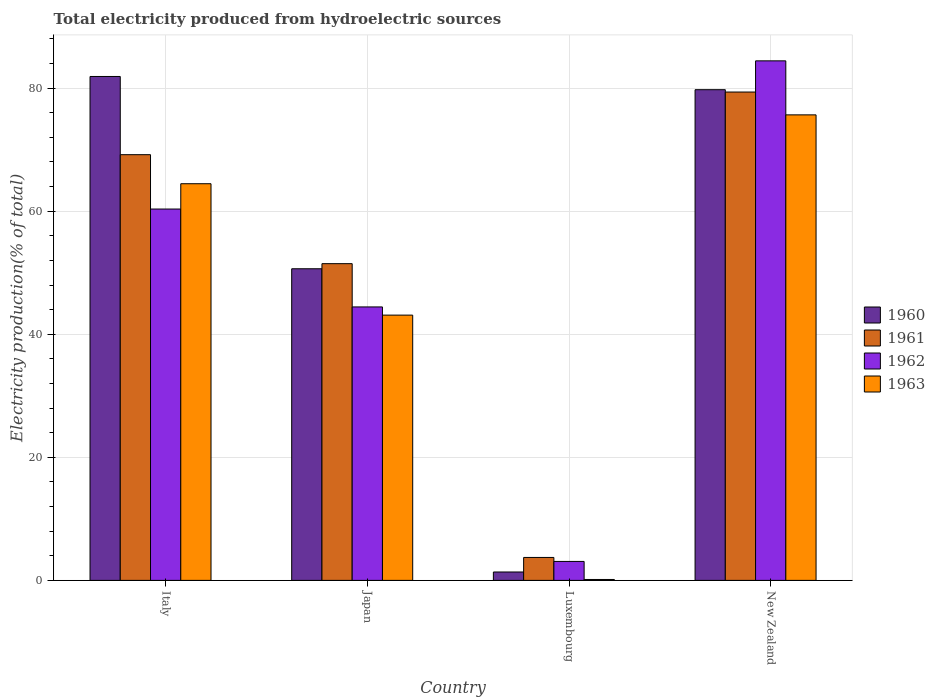How many groups of bars are there?
Make the answer very short. 4. Are the number of bars per tick equal to the number of legend labels?
Provide a short and direct response. Yes. Are the number of bars on each tick of the X-axis equal?
Your answer should be very brief. Yes. How many bars are there on the 2nd tick from the left?
Your answer should be compact. 4. What is the label of the 3rd group of bars from the left?
Offer a very short reply. Luxembourg. What is the total electricity produced in 1962 in Japan?
Offer a very short reply. 44.44. Across all countries, what is the maximum total electricity produced in 1963?
Your answer should be compact. 75.66. Across all countries, what is the minimum total electricity produced in 1961?
Ensure brevity in your answer.  3.73. In which country was the total electricity produced in 1962 maximum?
Your answer should be compact. New Zealand. In which country was the total electricity produced in 1963 minimum?
Keep it short and to the point. Luxembourg. What is the total total electricity produced in 1961 in the graph?
Your answer should be compact. 203.77. What is the difference between the total electricity produced in 1961 in Italy and that in New Zealand?
Your answer should be compact. -10.18. What is the difference between the total electricity produced in 1962 in Japan and the total electricity produced in 1963 in Italy?
Your response must be concise. -20.02. What is the average total electricity produced in 1962 per country?
Give a very brief answer. 48.08. What is the difference between the total electricity produced of/in 1962 and total electricity produced of/in 1961 in Italy?
Make the answer very short. -8.84. What is the ratio of the total electricity produced in 1962 in Japan to that in New Zealand?
Provide a short and direct response. 0.53. What is the difference between the highest and the second highest total electricity produced in 1961?
Provide a succinct answer. -17.71. What is the difference between the highest and the lowest total electricity produced in 1961?
Offer a terse response. 75.64. What does the 3rd bar from the right in Luxembourg represents?
Make the answer very short. 1961. Is it the case that in every country, the sum of the total electricity produced in 1963 and total electricity produced in 1960 is greater than the total electricity produced in 1962?
Keep it short and to the point. No. How many bars are there?
Offer a very short reply. 16. Are all the bars in the graph horizontal?
Your answer should be very brief. No. Does the graph contain any zero values?
Your answer should be very brief. No. Does the graph contain grids?
Your response must be concise. Yes. What is the title of the graph?
Ensure brevity in your answer.  Total electricity produced from hydroelectric sources. What is the label or title of the Y-axis?
Provide a succinct answer. Electricity production(% of total). What is the Electricity production(% of total) of 1960 in Italy?
Your response must be concise. 81.9. What is the Electricity production(% of total) in 1961 in Italy?
Provide a succinct answer. 69.19. What is the Electricity production(% of total) of 1962 in Italy?
Your answer should be compact. 60.35. What is the Electricity production(% of total) in 1963 in Italy?
Your answer should be compact. 64.47. What is the Electricity production(% of total) of 1960 in Japan?
Give a very brief answer. 50.65. What is the Electricity production(% of total) of 1961 in Japan?
Your response must be concise. 51.48. What is the Electricity production(% of total) in 1962 in Japan?
Ensure brevity in your answer.  44.44. What is the Electricity production(% of total) in 1963 in Japan?
Offer a terse response. 43.11. What is the Electricity production(% of total) in 1960 in Luxembourg?
Your answer should be compact. 1.37. What is the Electricity production(% of total) of 1961 in Luxembourg?
Ensure brevity in your answer.  3.73. What is the Electricity production(% of total) of 1962 in Luxembourg?
Provide a succinct answer. 3.08. What is the Electricity production(% of total) of 1963 in Luxembourg?
Your answer should be very brief. 0.15. What is the Electricity production(% of total) of 1960 in New Zealand?
Keep it short and to the point. 79.75. What is the Electricity production(% of total) of 1961 in New Zealand?
Offer a very short reply. 79.37. What is the Electricity production(% of total) in 1962 in New Zealand?
Ensure brevity in your answer.  84.44. What is the Electricity production(% of total) in 1963 in New Zealand?
Make the answer very short. 75.66. Across all countries, what is the maximum Electricity production(% of total) of 1960?
Your answer should be compact. 81.9. Across all countries, what is the maximum Electricity production(% of total) of 1961?
Make the answer very short. 79.37. Across all countries, what is the maximum Electricity production(% of total) in 1962?
Provide a succinct answer. 84.44. Across all countries, what is the maximum Electricity production(% of total) in 1963?
Your answer should be compact. 75.66. Across all countries, what is the minimum Electricity production(% of total) in 1960?
Ensure brevity in your answer.  1.37. Across all countries, what is the minimum Electricity production(% of total) in 1961?
Offer a very short reply. 3.73. Across all countries, what is the minimum Electricity production(% of total) of 1962?
Keep it short and to the point. 3.08. Across all countries, what is the minimum Electricity production(% of total) of 1963?
Your answer should be very brief. 0.15. What is the total Electricity production(% of total) of 1960 in the graph?
Keep it short and to the point. 213.67. What is the total Electricity production(% of total) in 1961 in the graph?
Your answer should be very brief. 203.77. What is the total Electricity production(% of total) in 1962 in the graph?
Ensure brevity in your answer.  192.32. What is the total Electricity production(% of total) in 1963 in the graph?
Your answer should be compact. 183.39. What is the difference between the Electricity production(% of total) of 1960 in Italy and that in Japan?
Your answer should be compact. 31.25. What is the difference between the Electricity production(% of total) in 1961 in Italy and that in Japan?
Keep it short and to the point. 17.71. What is the difference between the Electricity production(% of total) of 1962 in Italy and that in Japan?
Your response must be concise. 15.91. What is the difference between the Electricity production(% of total) in 1963 in Italy and that in Japan?
Offer a terse response. 21.35. What is the difference between the Electricity production(% of total) of 1960 in Italy and that in Luxembourg?
Give a very brief answer. 80.53. What is the difference between the Electricity production(% of total) of 1961 in Italy and that in Luxembourg?
Your answer should be compact. 65.46. What is the difference between the Electricity production(% of total) of 1962 in Italy and that in Luxembourg?
Offer a terse response. 57.27. What is the difference between the Electricity production(% of total) in 1963 in Italy and that in Luxembourg?
Your answer should be compact. 64.32. What is the difference between the Electricity production(% of total) of 1960 in Italy and that in New Zealand?
Ensure brevity in your answer.  2.15. What is the difference between the Electricity production(% of total) in 1961 in Italy and that in New Zealand?
Your response must be concise. -10.18. What is the difference between the Electricity production(% of total) of 1962 in Italy and that in New Zealand?
Ensure brevity in your answer.  -24.08. What is the difference between the Electricity production(% of total) of 1963 in Italy and that in New Zealand?
Offer a very short reply. -11.19. What is the difference between the Electricity production(% of total) in 1960 in Japan and that in Luxembourg?
Provide a succinct answer. 49.28. What is the difference between the Electricity production(% of total) of 1961 in Japan and that in Luxembourg?
Ensure brevity in your answer.  47.75. What is the difference between the Electricity production(% of total) in 1962 in Japan and that in Luxembourg?
Offer a very short reply. 41.36. What is the difference between the Electricity production(% of total) of 1963 in Japan and that in Luxembourg?
Keep it short and to the point. 42.97. What is the difference between the Electricity production(% of total) of 1960 in Japan and that in New Zealand?
Give a very brief answer. -29.1. What is the difference between the Electricity production(% of total) in 1961 in Japan and that in New Zealand?
Make the answer very short. -27.9. What is the difference between the Electricity production(% of total) of 1962 in Japan and that in New Zealand?
Give a very brief answer. -39.99. What is the difference between the Electricity production(% of total) in 1963 in Japan and that in New Zealand?
Your answer should be very brief. -32.54. What is the difference between the Electricity production(% of total) in 1960 in Luxembourg and that in New Zealand?
Offer a terse response. -78.38. What is the difference between the Electricity production(% of total) of 1961 in Luxembourg and that in New Zealand?
Give a very brief answer. -75.64. What is the difference between the Electricity production(% of total) of 1962 in Luxembourg and that in New Zealand?
Your answer should be very brief. -81.36. What is the difference between the Electricity production(% of total) of 1963 in Luxembourg and that in New Zealand?
Provide a short and direct response. -75.51. What is the difference between the Electricity production(% of total) in 1960 in Italy and the Electricity production(% of total) in 1961 in Japan?
Your answer should be compact. 30.42. What is the difference between the Electricity production(% of total) of 1960 in Italy and the Electricity production(% of total) of 1962 in Japan?
Provide a succinct answer. 37.46. What is the difference between the Electricity production(% of total) in 1960 in Italy and the Electricity production(% of total) in 1963 in Japan?
Offer a terse response. 38.79. What is the difference between the Electricity production(% of total) in 1961 in Italy and the Electricity production(% of total) in 1962 in Japan?
Your answer should be compact. 24.75. What is the difference between the Electricity production(% of total) in 1961 in Italy and the Electricity production(% of total) in 1963 in Japan?
Offer a terse response. 26.08. What is the difference between the Electricity production(% of total) in 1962 in Italy and the Electricity production(% of total) in 1963 in Japan?
Offer a terse response. 17.24. What is the difference between the Electricity production(% of total) of 1960 in Italy and the Electricity production(% of total) of 1961 in Luxembourg?
Provide a succinct answer. 78.17. What is the difference between the Electricity production(% of total) in 1960 in Italy and the Electricity production(% of total) in 1962 in Luxembourg?
Provide a succinct answer. 78.82. What is the difference between the Electricity production(% of total) in 1960 in Italy and the Electricity production(% of total) in 1963 in Luxembourg?
Make the answer very short. 81.75. What is the difference between the Electricity production(% of total) in 1961 in Italy and the Electricity production(% of total) in 1962 in Luxembourg?
Your answer should be very brief. 66.11. What is the difference between the Electricity production(% of total) in 1961 in Italy and the Electricity production(% of total) in 1963 in Luxembourg?
Give a very brief answer. 69.04. What is the difference between the Electricity production(% of total) of 1962 in Italy and the Electricity production(% of total) of 1963 in Luxembourg?
Offer a terse response. 60.21. What is the difference between the Electricity production(% of total) in 1960 in Italy and the Electricity production(% of total) in 1961 in New Zealand?
Your answer should be very brief. 2.53. What is the difference between the Electricity production(% of total) in 1960 in Italy and the Electricity production(% of total) in 1962 in New Zealand?
Make the answer very short. -2.54. What is the difference between the Electricity production(% of total) in 1960 in Italy and the Electricity production(% of total) in 1963 in New Zealand?
Give a very brief answer. 6.24. What is the difference between the Electricity production(% of total) of 1961 in Italy and the Electricity production(% of total) of 1962 in New Zealand?
Keep it short and to the point. -15.25. What is the difference between the Electricity production(% of total) in 1961 in Italy and the Electricity production(% of total) in 1963 in New Zealand?
Your response must be concise. -6.47. What is the difference between the Electricity production(% of total) in 1962 in Italy and the Electricity production(% of total) in 1963 in New Zealand?
Provide a succinct answer. -15.3. What is the difference between the Electricity production(% of total) in 1960 in Japan and the Electricity production(% of total) in 1961 in Luxembourg?
Give a very brief answer. 46.92. What is the difference between the Electricity production(% of total) of 1960 in Japan and the Electricity production(% of total) of 1962 in Luxembourg?
Keep it short and to the point. 47.57. What is the difference between the Electricity production(% of total) of 1960 in Japan and the Electricity production(% of total) of 1963 in Luxembourg?
Offer a very short reply. 50.5. What is the difference between the Electricity production(% of total) in 1961 in Japan and the Electricity production(% of total) in 1962 in Luxembourg?
Ensure brevity in your answer.  48.39. What is the difference between the Electricity production(% of total) of 1961 in Japan and the Electricity production(% of total) of 1963 in Luxembourg?
Provide a succinct answer. 51.33. What is the difference between the Electricity production(% of total) in 1962 in Japan and the Electricity production(% of total) in 1963 in Luxembourg?
Keep it short and to the point. 44.3. What is the difference between the Electricity production(% of total) in 1960 in Japan and the Electricity production(% of total) in 1961 in New Zealand?
Offer a terse response. -28.72. What is the difference between the Electricity production(% of total) of 1960 in Japan and the Electricity production(% of total) of 1962 in New Zealand?
Offer a terse response. -33.79. What is the difference between the Electricity production(% of total) in 1960 in Japan and the Electricity production(% of total) in 1963 in New Zealand?
Offer a terse response. -25.01. What is the difference between the Electricity production(% of total) in 1961 in Japan and the Electricity production(% of total) in 1962 in New Zealand?
Give a very brief answer. -32.96. What is the difference between the Electricity production(% of total) of 1961 in Japan and the Electricity production(% of total) of 1963 in New Zealand?
Offer a very short reply. -24.18. What is the difference between the Electricity production(% of total) in 1962 in Japan and the Electricity production(% of total) in 1963 in New Zealand?
Ensure brevity in your answer.  -31.21. What is the difference between the Electricity production(% of total) of 1960 in Luxembourg and the Electricity production(% of total) of 1961 in New Zealand?
Offer a very short reply. -78.01. What is the difference between the Electricity production(% of total) of 1960 in Luxembourg and the Electricity production(% of total) of 1962 in New Zealand?
Keep it short and to the point. -83.07. What is the difference between the Electricity production(% of total) in 1960 in Luxembourg and the Electricity production(% of total) in 1963 in New Zealand?
Offer a very short reply. -74.29. What is the difference between the Electricity production(% of total) in 1961 in Luxembourg and the Electricity production(% of total) in 1962 in New Zealand?
Your answer should be very brief. -80.71. What is the difference between the Electricity production(% of total) of 1961 in Luxembourg and the Electricity production(% of total) of 1963 in New Zealand?
Your answer should be compact. -71.93. What is the difference between the Electricity production(% of total) of 1962 in Luxembourg and the Electricity production(% of total) of 1963 in New Zealand?
Offer a terse response. -72.58. What is the average Electricity production(% of total) in 1960 per country?
Offer a very short reply. 53.42. What is the average Electricity production(% of total) in 1961 per country?
Your answer should be compact. 50.94. What is the average Electricity production(% of total) in 1962 per country?
Offer a terse response. 48.08. What is the average Electricity production(% of total) in 1963 per country?
Ensure brevity in your answer.  45.85. What is the difference between the Electricity production(% of total) in 1960 and Electricity production(% of total) in 1961 in Italy?
Keep it short and to the point. 12.71. What is the difference between the Electricity production(% of total) of 1960 and Electricity production(% of total) of 1962 in Italy?
Provide a succinct answer. 21.55. What is the difference between the Electricity production(% of total) in 1960 and Electricity production(% of total) in 1963 in Italy?
Your answer should be compact. 17.43. What is the difference between the Electricity production(% of total) in 1961 and Electricity production(% of total) in 1962 in Italy?
Make the answer very short. 8.84. What is the difference between the Electricity production(% of total) of 1961 and Electricity production(% of total) of 1963 in Italy?
Your answer should be very brief. 4.72. What is the difference between the Electricity production(% of total) of 1962 and Electricity production(% of total) of 1963 in Italy?
Make the answer very short. -4.11. What is the difference between the Electricity production(% of total) of 1960 and Electricity production(% of total) of 1961 in Japan?
Offer a terse response. -0.83. What is the difference between the Electricity production(% of total) of 1960 and Electricity production(% of total) of 1962 in Japan?
Provide a short and direct response. 6.2. What is the difference between the Electricity production(% of total) of 1960 and Electricity production(% of total) of 1963 in Japan?
Offer a terse response. 7.54. What is the difference between the Electricity production(% of total) of 1961 and Electricity production(% of total) of 1962 in Japan?
Provide a succinct answer. 7.03. What is the difference between the Electricity production(% of total) of 1961 and Electricity production(% of total) of 1963 in Japan?
Give a very brief answer. 8.36. What is the difference between the Electricity production(% of total) in 1962 and Electricity production(% of total) in 1963 in Japan?
Your answer should be very brief. 1.33. What is the difference between the Electricity production(% of total) in 1960 and Electricity production(% of total) in 1961 in Luxembourg?
Offer a very short reply. -2.36. What is the difference between the Electricity production(% of total) of 1960 and Electricity production(% of total) of 1962 in Luxembourg?
Provide a succinct answer. -1.72. What is the difference between the Electricity production(% of total) in 1960 and Electricity production(% of total) in 1963 in Luxembourg?
Give a very brief answer. 1.22. What is the difference between the Electricity production(% of total) of 1961 and Electricity production(% of total) of 1962 in Luxembourg?
Offer a terse response. 0.65. What is the difference between the Electricity production(% of total) of 1961 and Electricity production(% of total) of 1963 in Luxembourg?
Offer a terse response. 3.58. What is the difference between the Electricity production(% of total) of 1962 and Electricity production(% of total) of 1963 in Luxembourg?
Ensure brevity in your answer.  2.93. What is the difference between the Electricity production(% of total) of 1960 and Electricity production(% of total) of 1961 in New Zealand?
Make the answer very short. 0.38. What is the difference between the Electricity production(% of total) in 1960 and Electricity production(% of total) in 1962 in New Zealand?
Your response must be concise. -4.69. What is the difference between the Electricity production(% of total) of 1960 and Electricity production(% of total) of 1963 in New Zealand?
Offer a very short reply. 4.09. What is the difference between the Electricity production(% of total) of 1961 and Electricity production(% of total) of 1962 in New Zealand?
Offer a very short reply. -5.07. What is the difference between the Electricity production(% of total) of 1961 and Electricity production(% of total) of 1963 in New Zealand?
Provide a succinct answer. 3.71. What is the difference between the Electricity production(% of total) in 1962 and Electricity production(% of total) in 1963 in New Zealand?
Give a very brief answer. 8.78. What is the ratio of the Electricity production(% of total) in 1960 in Italy to that in Japan?
Your response must be concise. 1.62. What is the ratio of the Electricity production(% of total) in 1961 in Italy to that in Japan?
Provide a succinct answer. 1.34. What is the ratio of the Electricity production(% of total) in 1962 in Italy to that in Japan?
Your answer should be very brief. 1.36. What is the ratio of the Electricity production(% of total) of 1963 in Italy to that in Japan?
Your answer should be compact. 1.5. What is the ratio of the Electricity production(% of total) of 1960 in Italy to that in Luxembourg?
Provide a succinct answer. 59.95. What is the ratio of the Electricity production(% of total) of 1961 in Italy to that in Luxembourg?
Ensure brevity in your answer.  18.55. What is the ratio of the Electricity production(% of total) of 1962 in Italy to that in Luxembourg?
Give a very brief answer. 19.58. What is the ratio of the Electricity production(% of total) of 1963 in Italy to that in Luxembourg?
Give a very brief answer. 436.77. What is the ratio of the Electricity production(% of total) in 1961 in Italy to that in New Zealand?
Offer a very short reply. 0.87. What is the ratio of the Electricity production(% of total) in 1962 in Italy to that in New Zealand?
Give a very brief answer. 0.71. What is the ratio of the Electricity production(% of total) in 1963 in Italy to that in New Zealand?
Provide a succinct answer. 0.85. What is the ratio of the Electricity production(% of total) in 1960 in Japan to that in Luxembourg?
Your answer should be compact. 37.08. What is the ratio of the Electricity production(% of total) of 1961 in Japan to that in Luxembourg?
Ensure brevity in your answer.  13.8. What is the ratio of the Electricity production(% of total) in 1962 in Japan to that in Luxembourg?
Ensure brevity in your answer.  14.42. What is the ratio of the Electricity production(% of total) of 1963 in Japan to that in Luxembourg?
Provide a succinct answer. 292.1. What is the ratio of the Electricity production(% of total) of 1960 in Japan to that in New Zealand?
Your response must be concise. 0.64. What is the ratio of the Electricity production(% of total) of 1961 in Japan to that in New Zealand?
Your answer should be very brief. 0.65. What is the ratio of the Electricity production(% of total) in 1962 in Japan to that in New Zealand?
Give a very brief answer. 0.53. What is the ratio of the Electricity production(% of total) in 1963 in Japan to that in New Zealand?
Your answer should be compact. 0.57. What is the ratio of the Electricity production(% of total) in 1960 in Luxembourg to that in New Zealand?
Your answer should be very brief. 0.02. What is the ratio of the Electricity production(% of total) in 1961 in Luxembourg to that in New Zealand?
Keep it short and to the point. 0.05. What is the ratio of the Electricity production(% of total) of 1962 in Luxembourg to that in New Zealand?
Offer a terse response. 0.04. What is the ratio of the Electricity production(% of total) in 1963 in Luxembourg to that in New Zealand?
Ensure brevity in your answer.  0. What is the difference between the highest and the second highest Electricity production(% of total) of 1960?
Provide a short and direct response. 2.15. What is the difference between the highest and the second highest Electricity production(% of total) of 1961?
Provide a succinct answer. 10.18. What is the difference between the highest and the second highest Electricity production(% of total) of 1962?
Give a very brief answer. 24.08. What is the difference between the highest and the second highest Electricity production(% of total) in 1963?
Keep it short and to the point. 11.19. What is the difference between the highest and the lowest Electricity production(% of total) in 1960?
Provide a short and direct response. 80.53. What is the difference between the highest and the lowest Electricity production(% of total) of 1961?
Give a very brief answer. 75.64. What is the difference between the highest and the lowest Electricity production(% of total) in 1962?
Keep it short and to the point. 81.36. What is the difference between the highest and the lowest Electricity production(% of total) in 1963?
Offer a terse response. 75.51. 